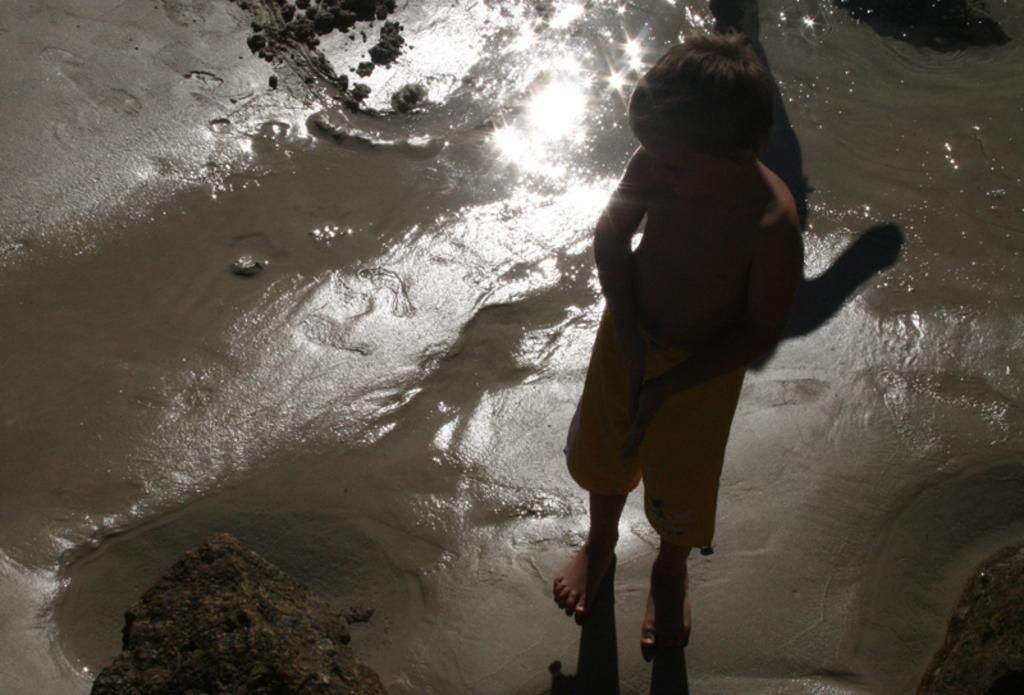Please provide a concise description of this image. In this picture we can see a boy is standing on the sand and behind the boy there is the water. In front of the boy it looks like a rock. 